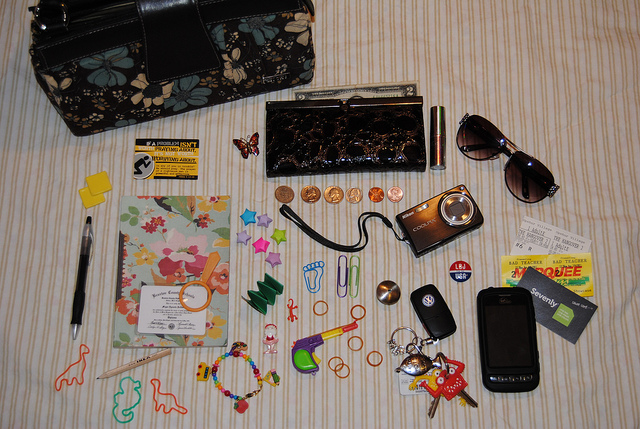Please identify all text content in this image. MARQUEE USA 